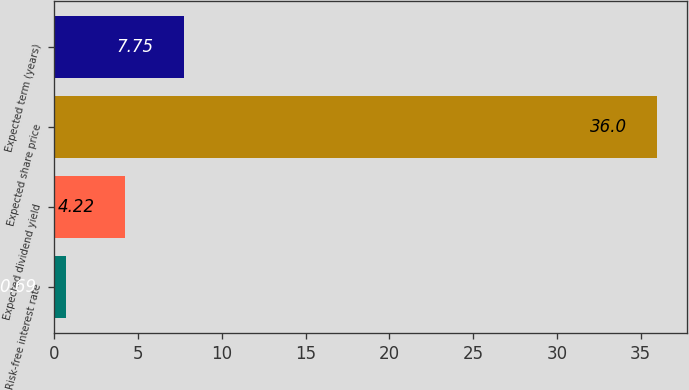<chart> <loc_0><loc_0><loc_500><loc_500><bar_chart><fcel>Risk-free interest rate<fcel>Expected dividend yield<fcel>Expected share price<fcel>Expected term (years)<nl><fcel>0.69<fcel>4.22<fcel>36<fcel>7.75<nl></chart> 